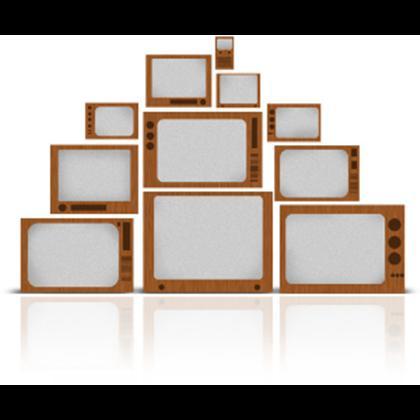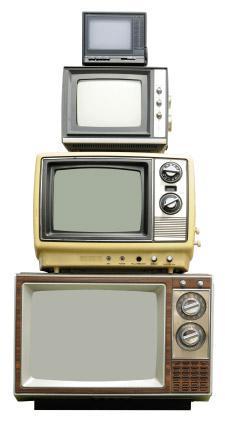The first image is the image on the left, the second image is the image on the right. Examine the images to the left and right. Is the description "tv's are stacked in a triangular shape" accurate? Answer yes or no. Yes. The first image is the image on the left, the second image is the image on the right. For the images displayed, is the sentence "Both images contain an equal number of monitors." factually correct? Answer yes or no. No. 